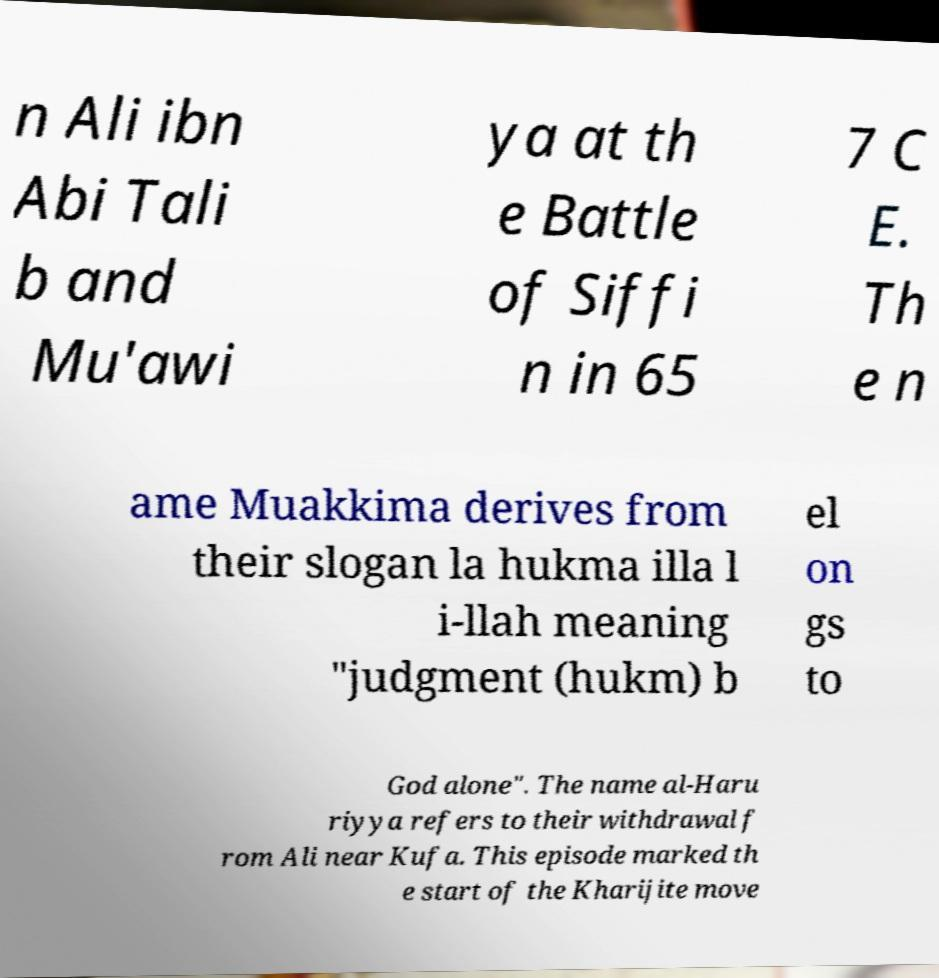Could you extract and type out the text from this image? n Ali ibn Abi Tali b and Mu'awi ya at th e Battle of Siffi n in 65 7 C E. Th e n ame Muakkima derives from their slogan la hukma illa l i-llah meaning "judgment (hukm) b el on gs to God alone". The name al-Haru riyya refers to their withdrawal f rom Ali near Kufa. This episode marked th e start of the Kharijite move 